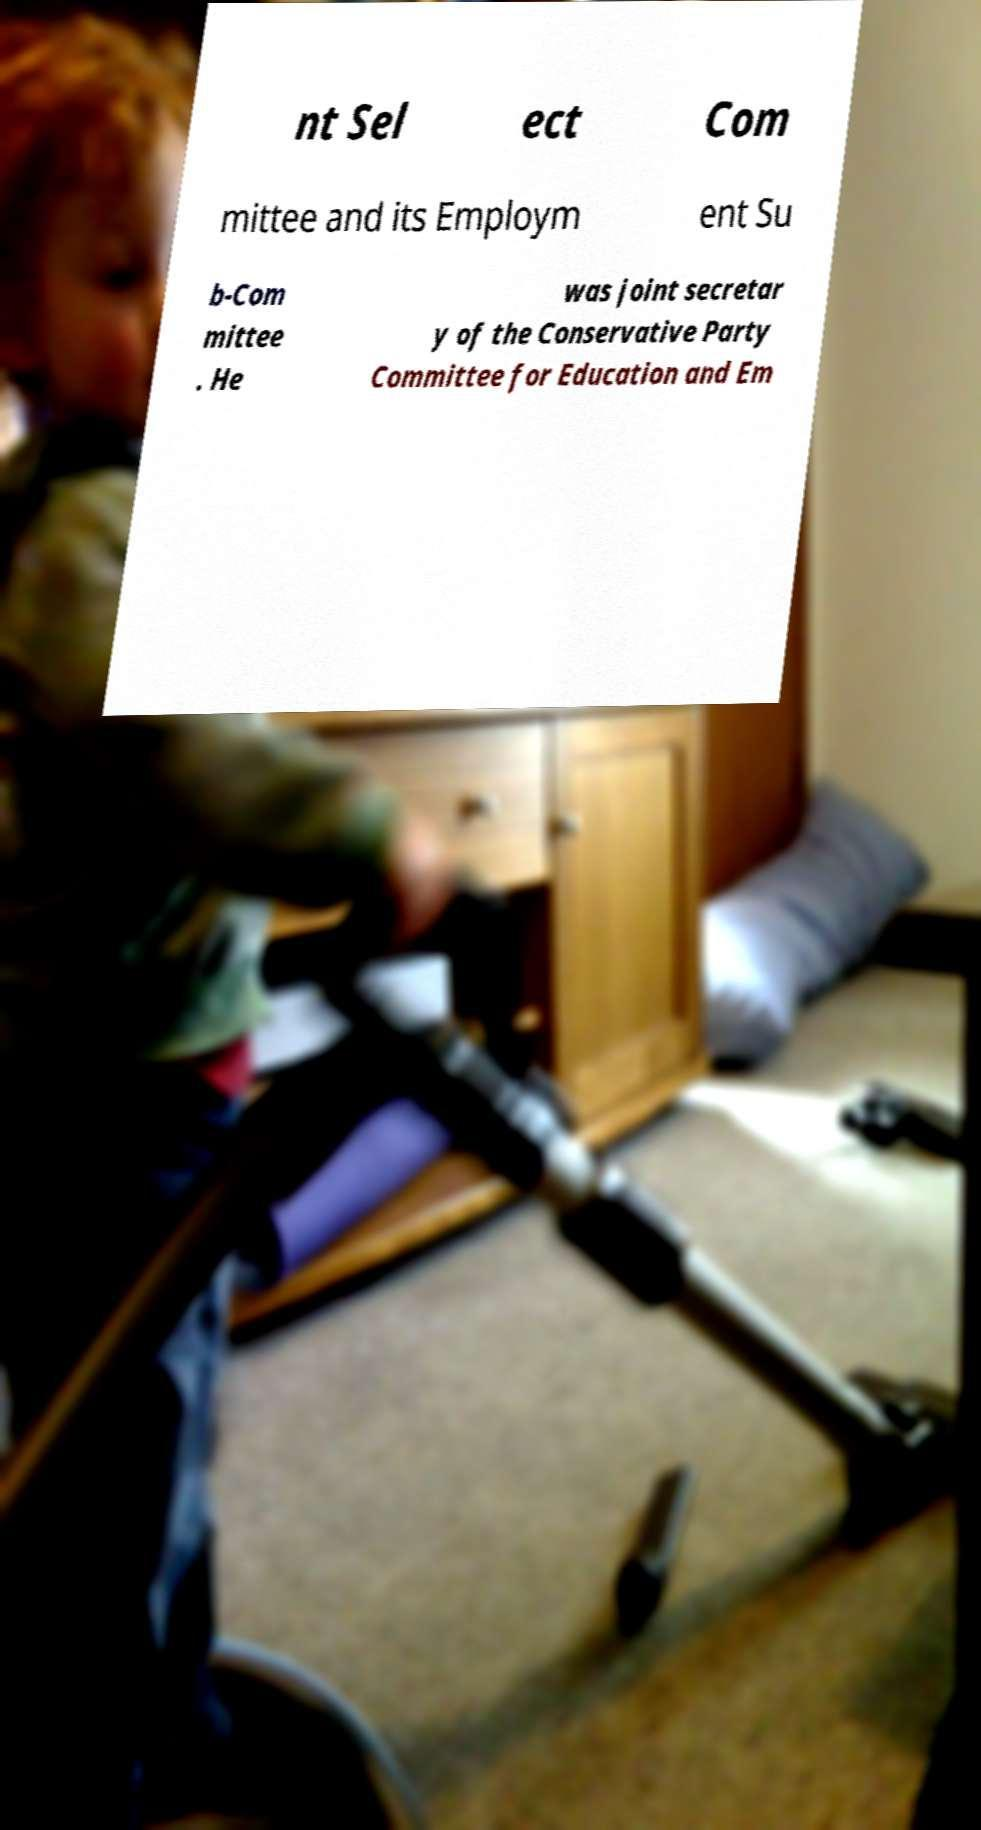Please read and relay the text visible in this image. What does it say? nt Sel ect Com mittee and its Employm ent Su b-Com mittee . He was joint secretar y of the Conservative Party Committee for Education and Em 